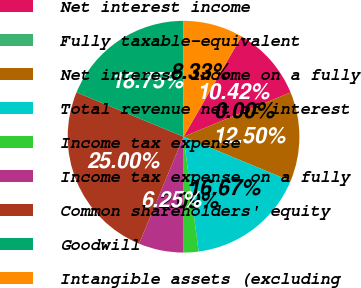Convert chart to OTSL. <chart><loc_0><loc_0><loc_500><loc_500><pie_chart><fcel>Net interest income<fcel>Fully taxable-equivalent<fcel>Net interest income on a fully<fcel>Total revenue net of interest<fcel>Income tax expense<fcel>Income tax expense on a fully<fcel>Common shareholders' equity<fcel>Goodwill<fcel>Intangible assets (excluding<nl><fcel>10.42%<fcel>0.0%<fcel>12.5%<fcel>16.67%<fcel>2.09%<fcel>6.25%<fcel>25.0%<fcel>18.75%<fcel>8.33%<nl></chart> 